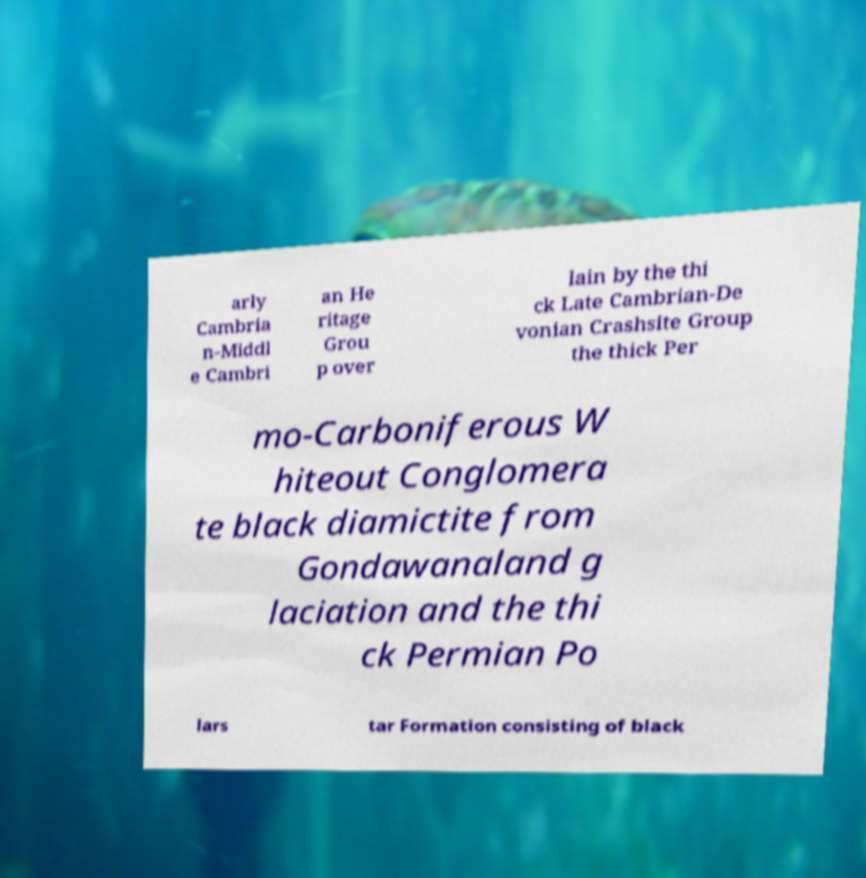Can you read and provide the text displayed in the image?This photo seems to have some interesting text. Can you extract and type it out for me? arly Cambria n-Middl e Cambri an He ritage Grou p over lain by the thi ck Late Cambrian-De vonian Crashsite Group the thick Per mo-Carboniferous W hiteout Conglomera te black diamictite from Gondawanaland g laciation and the thi ck Permian Po lars tar Formation consisting of black 